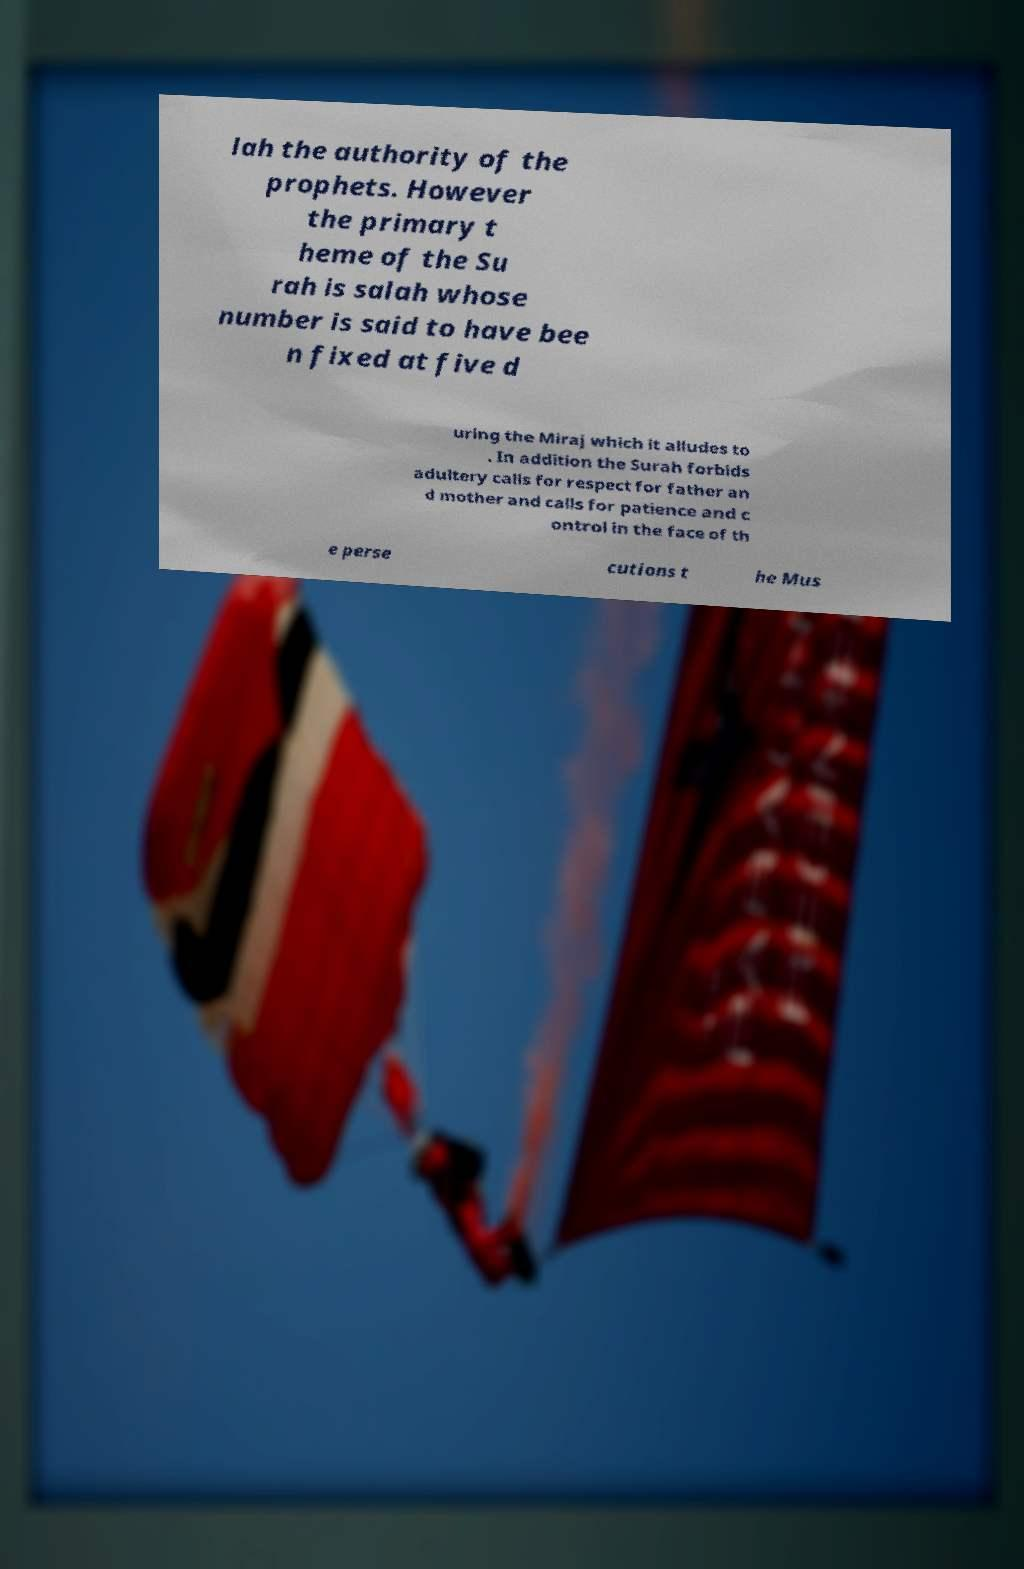Please identify and transcribe the text found in this image. lah the authority of the prophets. However the primary t heme of the Su rah is salah whose number is said to have bee n fixed at five d uring the Miraj which it alludes to . In addition the Surah forbids adultery calls for respect for father an d mother and calls for patience and c ontrol in the face of th e perse cutions t he Mus 